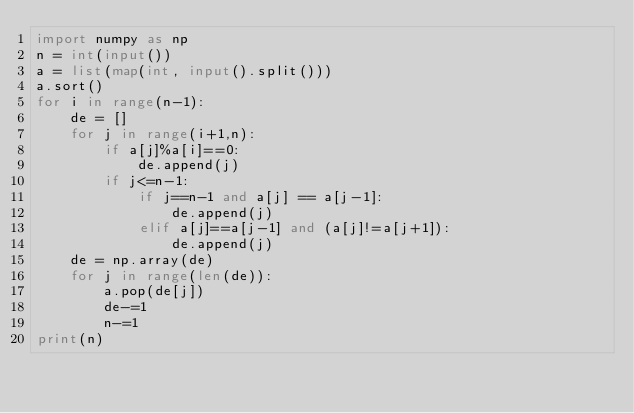Convert code to text. <code><loc_0><loc_0><loc_500><loc_500><_Python_>import numpy as np
n = int(input())
a = list(map(int, input().split()))
a.sort()
for i in range(n-1):
    de = []
    for j in range(i+1,n):
        if a[j]%a[i]==0:
            de.append(j)
        if j<=n-1:
            if j==n-1 and a[j] == a[j-1]:
                de.append(j)
            elif a[j]==a[j-1] and (a[j]!=a[j+1]):
                de.append(j)
    de = np.array(de)
    for j in range(len(de)):
        a.pop(de[j])
        de-=1
        n-=1
print(n)</code> 